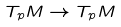<formula> <loc_0><loc_0><loc_500><loc_500>T _ { p } M \rightarrow T _ { p } M</formula> 